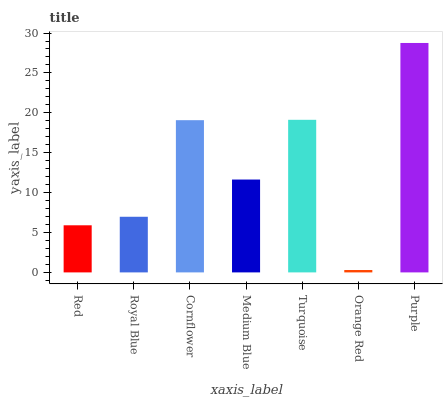Is Orange Red the minimum?
Answer yes or no. Yes. Is Purple the maximum?
Answer yes or no. Yes. Is Royal Blue the minimum?
Answer yes or no. No. Is Royal Blue the maximum?
Answer yes or no. No. Is Royal Blue greater than Red?
Answer yes or no. Yes. Is Red less than Royal Blue?
Answer yes or no. Yes. Is Red greater than Royal Blue?
Answer yes or no. No. Is Royal Blue less than Red?
Answer yes or no. No. Is Medium Blue the high median?
Answer yes or no. Yes. Is Medium Blue the low median?
Answer yes or no. Yes. Is Orange Red the high median?
Answer yes or no. No. Is Royal Blue the low median?
Answer yes or no. No. 